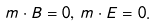Convert formula to latex. <formula><loc_0><loc_0><loc_500><loc_500>m \cdot B = 0 , \, m \cdot E = 0 .</formula> 